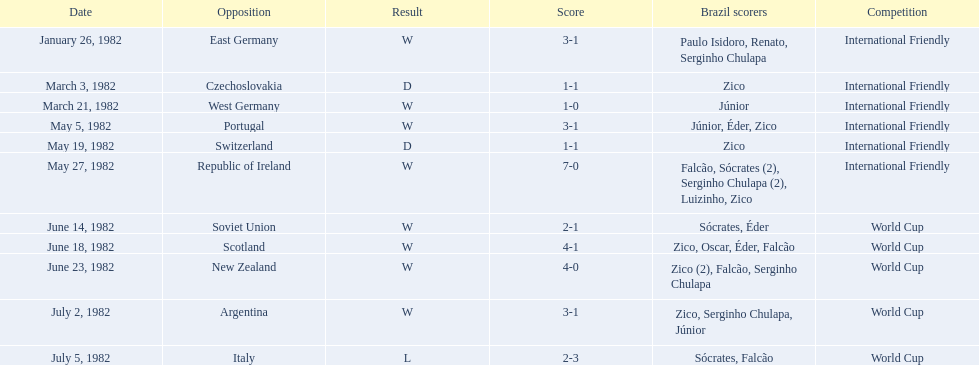What were the individual scores for each match in the 1982 brazilian football games? 3-1, 1-1, 1-0, 3-1, 1-1, 7-0, 2-1, 4-1, 4-0, 3-1, 2-3. Specifically, what were the scores for the matches against portugal and the soviet union? 3-1, 2-1. Among those two matches, which one had brazil scoring more goals? Portugal. 